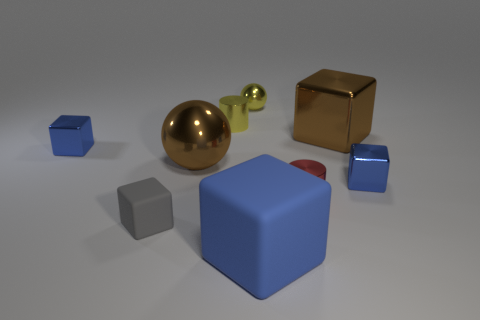Subtract all blue shiny cubes. How many cubes are left? 3 Add 1 gray cubes. How many objects exist? 10 Subtract all cubes. How many objects are left? 4 Subtract all cyan cylinders. How many blue cubes are left? 3 Subtract all gray cubes. How many cubes are left? 4 Subtract all big metallic balls. Subtract all tiny gray rubber things. How many objects are left? 7 Add 7 yellow spheres. How many yellow spheres are left? 8 Add 4 tiny yellow rubber balls. How many tiny yellow rubber balls exist? 4 Subtract 1 brown blocks. How many objects are left? 8 Subtract 1 blocks. How many blocks are left? 4 